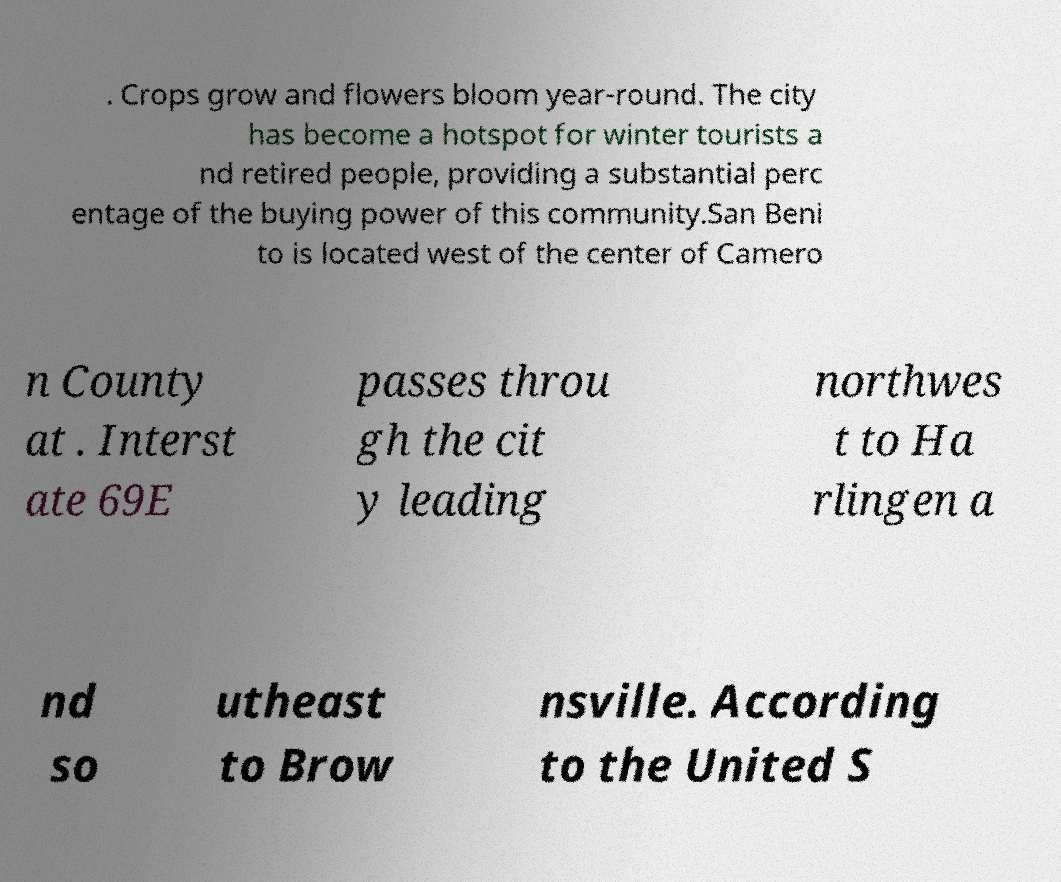Could you extract and type out the text from this image? . Crops grow and flowers bloom year-round. The city has become a hotspot for winter tourists a nd retired people, providing a substantial perc entage of the buying power of this community.San Beni to is located west of the center of Camero n County at . Interst ate 69E passes throu gh the cit y leading northwes t to Ha rlingen a nd so utheast to Brow nsville. According to the United S 